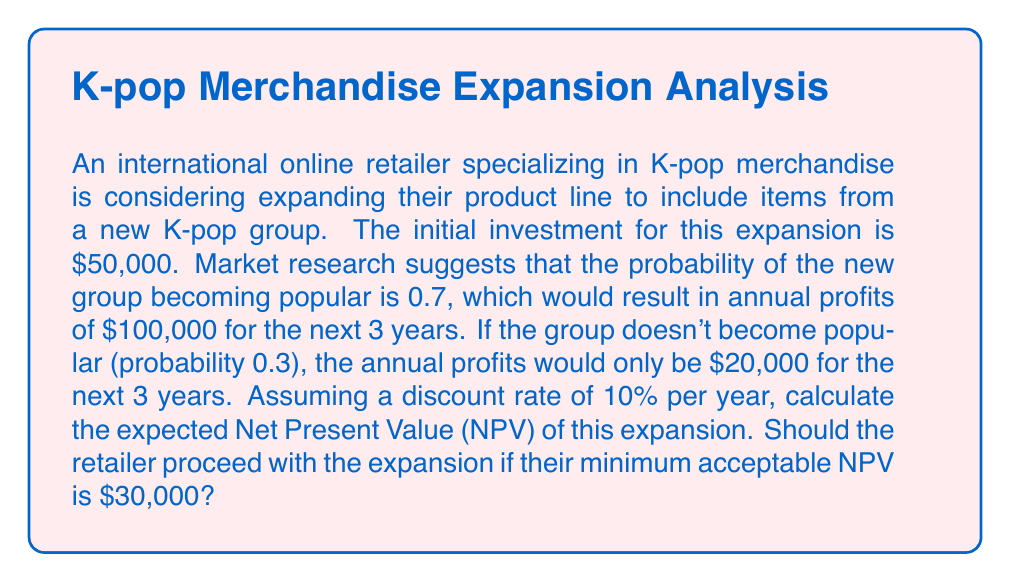Solve this math problem. To solve this problem, we need to calculate the expected Net Present Value (NPV) of the expansion. Let's break it down step by step:

1. Calculate the present value of cash flows for each scenario:

   a) If the group becomes popular (probability 0.7):
      $$PV_{popular} = -50,000 + \frac{100,000}{(1+0.1)^1} + \frac{100,000}{(1+0.1)^2} + \frac{100,000}{(1+0.1)^3}$$

   b) If the group doesn't become popular (probability 0.3):
      $$PV_{unpopular} = -50,000 + \frac{20,000}{(1+0.1)^1} + \frac{20,000}{(1+0.1)^2} + \frac{20,000}{(1+0.1)^3}$$

2. Calculate the values:
   $$PV_{popular} = -50,000 + 90,909.09 + 82,644.63 + 75,131.48 = 198,685.20$$
   $$PV_{unpopular} = -50,000 + 18,181.82 + 16,528.93 + 15,026.30 = -263.95$$

3. Calculate the expected NPV using the probabilities:
   $$E[NPV] = 0.7 \times PV_{popular} + 0.3 \times PV_{unpopular}$$
   $$E[NPV] = 0.7 \times 198,685.20 + 0.3 \times (-263.95)$$
   $$E[NPV] = 139,079.64 - 79.19 = 138,920.45$$

4. Compare the expected NPV to the minimum acceptable NPV:
   The expected NPV ($138,920.45) is greater than the minimum acceptable NPV ($30,000).
Answer: The expected Net Present Value (NPV) of the expansion is $138,920.45. Since this is greater than the minimum acceptable NPV of $30,000, the retailer should proceed with the expansion. 